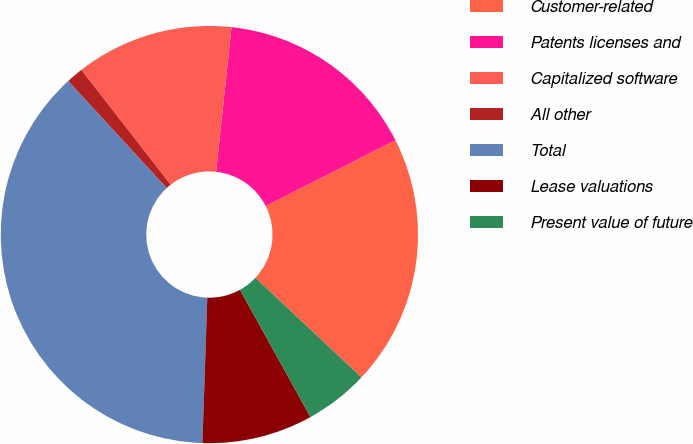<chart> <loc_0><loc_0><loc_500><loc_500><pie_chart><fcel>Customer-related<fcel>Patents licenses and<fcel>Capitalized software<fcel>All other<fcel>Total<fcel>Lease valuations<fcel>Present value of future<nl><fcel>19.47%<fcel>15.84%<fcel>12.21%<fcel>1.32%<fcel>37.63%<fcel>8.58%<fcel>4.95%<nl></chart> 